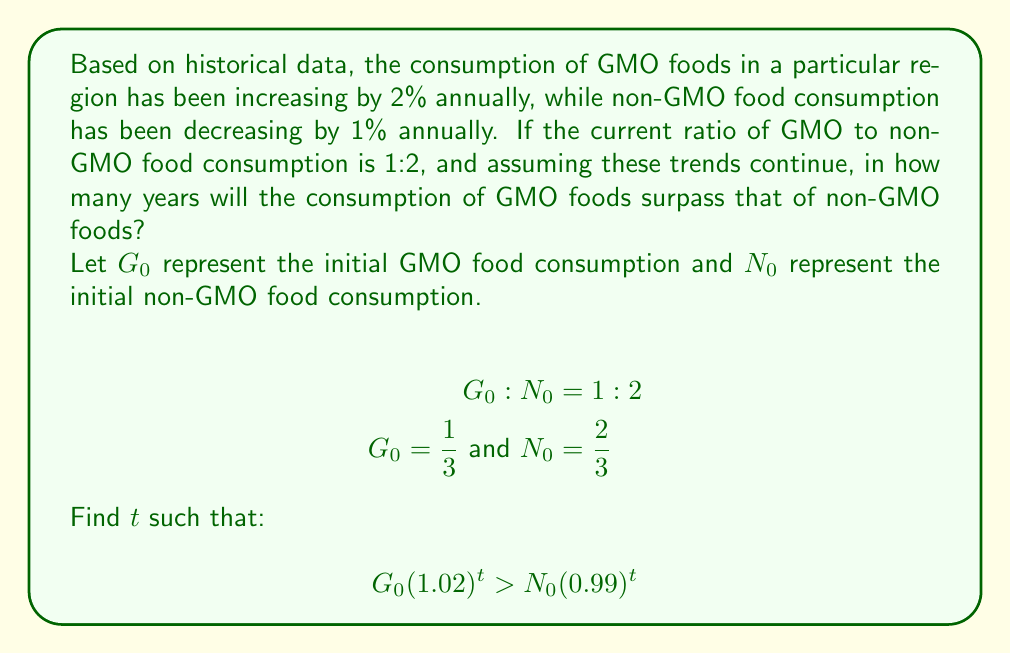What is the answer to this math problem? To solve this problem, we need to find the year when GMO food consumption surpasses non-GMO food consumption. Let's approach this step-by-step:

1) We start with the inequality:
   $$G_0(1.02)^t > N_0(0.99)^t$$

2) Substituting the initial values:
   $$\frac{1}{3}(1.02)^t > \frac{2}{3}(0.99)^t$$

3) Multiply both sides by 3:
   $$(1.02)^t > 2(0.99)^t$$

4) Divide both sides by $(0.99)^t$:
   $$(\frac{1.02}{0.99})^t > 2$$

5) Take the natural logarithm of both sides:
   $$t \ln(\frac{1.02}{0.99}) > \ln(2)$$

6) Solve for $t$:
   $$t > \frac{\ln(2)}{\ln(\frac{1.02}{0.99})}$$

7) Calculate the value:
   $$t > \frac{0.6931}{0.0301} \approx 23.03$$

Since we're looking for the first year when GMO consumption surpasses non-GMO consumption, we need to round up to the next whole number.
Answer: 24 years 